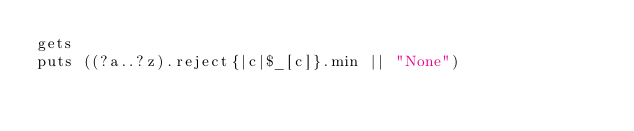Convert code to text. <code><loc_0><loc_0><loc_500><loc_500><_Ruby_>gets
puts ((?a..?z).reject{|c|$_[c]}.min || "None")
</code> 